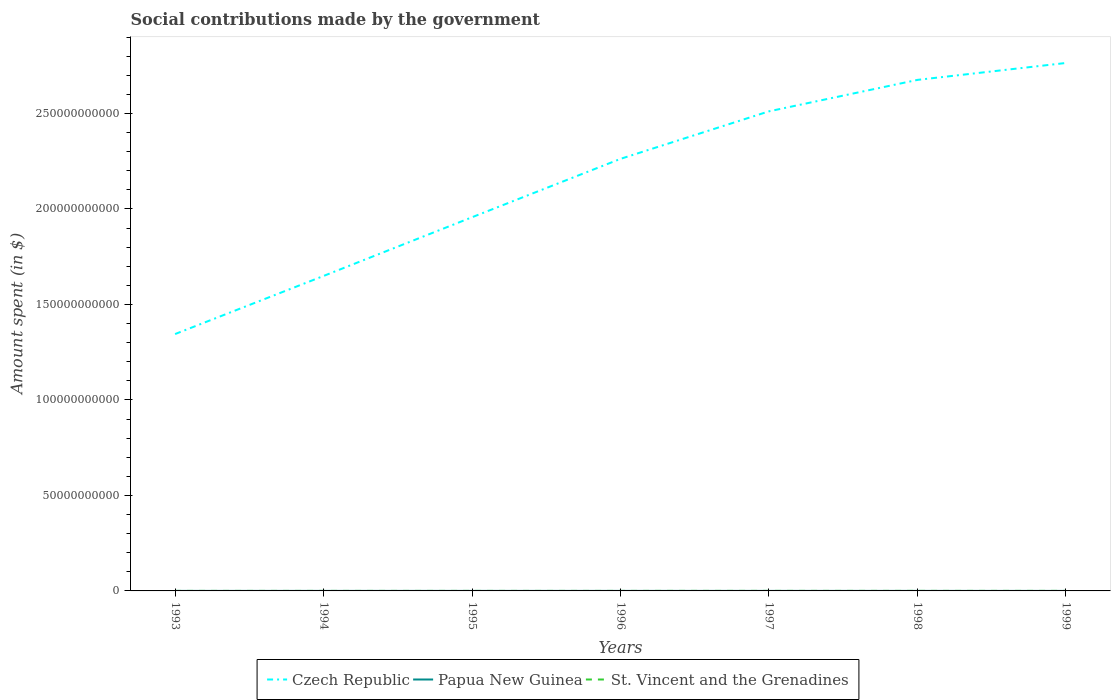How many different coloured lines are there?
Make the answer very short. 3. Does the line corresponding to St. Vincent and the Grenadines intersect with the line corresponding to Czech Republic?
Keep it short and to the point. No. Is the number of lines equal to the number of legend labels?
Give a very brief answer. Yes. Across all years, what is the maximum amount spent on social contributions in St. Vincent and the Grenadines?
Give a very brief answer. 9.10e+06. In which year was the amount spent on social contributions in St. Vincent and the Grenadines maximum?
Keep it short and to the point. 1993. What is the total amount spent on social contributions in St. Vincent and the Grenadines in the graph?
Provide a short and direct response. -2.50e+06. What is the difference between the highest and the second highest amount spent on social contributions in St. Vincent and the Grenadines?
Make the answer very short. 7.00e+06. How many lines are there?
Make the answer very short. 3. How many years are there in the graph?
Offer a very short reply. 7. Does the graph contain any zero values?
Offer a terse response. No. How many legend labels are there?
Give a very brief answer. 3. What is the title of the graph?
Provide a short and direct response. Social contributions made by the government. Does "Grenada" appear as one of the legend labels in the graph?
Keep it short and to the point. No. What is the label or title of the X-axis?
Offer a very short reply. Years. What is the label or title of the Y-axis?
Ensure brevity in your answer.  Amount spent (in $). What is the Amount spent (in $) in Czech Republic in 1993?
Provide a short and direct response. 1.34e+11. What is the Amount spent (in $) in Papua New Guinea in 1993?
Ensure brevity in your answer.  6.53e+06. What is the Amount spent (in $) in St. Vincent and the Grenadines in 1993?
Provide a short and direct response. 9.10e+06. What is the Amount spent (in $) in Czech Republic in 1994?
Keep it short and to the point. 1.65e+11. What is the Amount spent (in $) in Papua New Guinea in 1994?
Offer a terse response. 6.30e+06. What is the Amount spent (in $) of St. Vincent and the Grenadines in 1994?
Provide a short and direct response. 9.50e+06. What is the Amount spent (in $) of Czech Republic in 1995?
Offer a terse response. 1.96e+11. What is the Amount spent (in $) in Papua New Guinea in 1995?
Your answer should be very brief. 7.29e+06. What is the Amount spent (in $) of St. Vincent and the Grenadines in 1995?
Ensure brevity in your answer.  1.07e+07. What is the Amount spent (in $) in Czech Republic in 1996?
Make the answer very short. 2.26e+11. What is the Amount spent (in $) of Papua New Guinea in 1996?
Offer a terse response. 7.87e+06. What is the Amount spent (in $) in St. Vincent and the Grenadines in 1996?
Keep it short and to the point. 1.16e+07. What is the Amount spent (in $) in Czech Republic in 1997?
Your answer should be compact. 2.51e+11. What is the Amount spent (in $) of Papua New Guinea in 1997?
Your answer should be very brief. 5.77e+06. What is the Amount spent (in $) of St. Vincent and the Grenadines in 1997?
Keep it short and to the point. 1.36e+07. What is the Amount spent (in $) of Czech Republic in 1998?
Your answer should be very brief. 2.68e+11. What is the Amount spent (in $) of Papua New Guinea in 1998?
Your answer should be very brief. 4.65e+06. What is the Amount spent (in $) of St. Vincent and the Grenadines in 1998?
Your answer should be compact. 1.54e+07. What is the Amount spent (in $) in Czech Republic in 1999?
Your answer should be compact. 2.76e+11. What is the Amount spent (in $) of Papua New Guinea in 1999?
Give a very brief answer. 3.53e+06. What is the Amount spent (in $) of St. Vincent and the Grenadines in 1999?
Your response must be concise. 1.61e+07. Across all years, what is the maximum Amount spent (in $) in Czech Republic?
Your answer should be very brief. 2.76e+11. Across all years, what is the maximum Amount spent (in $) in Papua New Guinea?
Provide a short and direct response. 7.87e+06. Across all years, what is the maximum Amount spent (in $) of St. Vincent and the Grenadines?
Provide a succinct answer. 1.61e+07. Across all years, what is the minimum Amount spent (in $) in Czech Republic?
Keep it short and to the point. 1.34e+11. Across all years, what is the minimum Amount spent (in $) of Papua New Guinea?
Offer a very short reply. 3.53e+06. Across all years, what is the minimum Amount spent (in $) of St. Vincent and the Grenadines?
Offer a terse response. 9.10e+06. What is the total Amount spent (in $) in Czech Republic in the graph?
Make the answer very short. 1.52e+12. What is the total Amount spent (in $) in Papua New Guinea in the graph?
Provide a succinct answer. 4.19e+07. What is the total Amount spent (in $) in St. Vincent and the Grenadines in the graph?
Your answer should be compact. 8.60e+07. What is the difference between the Amount spent (in $) in Czech Republic in 1993 and that in 1994?
Offer a terse response. -3.04e+1. What is the difference between the Amount spent (in $) in Papua New Guinea in 1993 and that in 1994?
Keep it short and to the point. 2.26e+05. What is the difference between the Amount spent (in $) in St. Vincent and the Grenadines in 1993 and that in 1994?
Ensure brevity in your answer.  -4.00e+05. What is the difference between the Amount spent (in $) in Czech Republic in 1993 and that in 1995?
Your answer should be compact. -6.12e+1. What is the difference between the Amount spent (in $) in Papua New Guinea in 1993 and that in 1995?
Your answer should be compact. -7.57e+05. What is the difference between the Amount spent (in $) of St. Vincent and the Grenadines in 1993 and that in 1995?
Your answer should be very brief. -1.60e+06. What is the difference between the Amount spent (in $) of Czech Republic in 1993 and that in 1996?
Offer a very short reply. -9.17e+1. What is the difference between the Amount spent (in $) in Papua New Guinea in 1993 and that in 1996?
Keep it short and to the point. -1.34e+06. What is the difference between the Amount spent (in $) of St. Vincent and the Grenadines in 1993 and that in 1996?
Provide a short and direct response. -2.50e+06. What is the difference between the Amount spent (in $) in Czech Republic in 1993 and that in 1997?
Your answer should be compact. -1.17e+11. What is the difference between the Amount spent (in $) of Papua New Guinea in 1993 and that in 1997?
Keep it short and to the point. 7.60e+05. What is the difference between the Amount spent (in $) of St. Vincent and the Grenadines in 1993 and that in 1997?
Provide a short and direct response. -4.50e+06. What is the difference between the Amount spent (in $) in Czech Republic in 1993 and that in 1998?
Offer a terse response. -1.33e+11. What is the difference between the Amount spent (in $) of Papua New Guinea in 1993 and that in 1998?
Keep it short and to the point. 1.88e+06. What is the difference between the Amount spent (in $) of St. Vincent and the Grenadines in 1993 and that in 1998?
Your answer should be very brief. -6.30e+06. What is the difference between the Amount spent (in $) of Czech Republic in 1993 and that in 1999?
Make the answer very short. -1.42e+11. What is the difference between the Amount spent (in $) of Papua New Guinea in 1993 and that in 1999?
Your answer should be very brief. 3.00e+06. What is the difference between the Amount spent (in $) of St. Vincent and the Grenadines in 1993 and that in 1999?
Your response must be concise. -7.00e+06. What is the difference between the Amount spent (in $) in Czech Republic in 1994 and that in 1995?
Your response must be concise. -3.07e+1. What is the difference between the Amount spent (in $) of Papua New Guinea in 1994 and that in 1995?
Your response must be concise. -9.83e+05. What is the difference between the Amount spent (in $) in St. Vincent and the Grenadines in 1994 and that in 1995?
Offer a terse response. -1.20e+06. What is the difference between the Amount spent (in $) of Czech Republic in 1994 and that in 1996?
Your response must be concise. -6.13e+1. What is the difference between the Amount spent (in $) in Papua New Guinea in 1994 and that in 1996?
Give a very brief answer. -1.57e+06. What is the difference between the Amount spent (in $) of St. Vincent and the Grenadines in 1994 and that in 1996?
Offer a very short reply. -2.10e+06. What is the difference between the Amount spent (in $) of Czech Republic in 1994 and that in 1997?
Offer a very short reply. -8.62e+1. What is the difference between the Amount spent (in $) of Papua New Guinea in 1994 and that in 1997?
Provide a succinct answer. 5.34e+05. What is the difference between the Amount spent (in $) in St. Vincent and the Grenadines in 1994 and that in 1997?
Your response must be concise. -4.10e+06. What is the difference between the Amount spent (in $) of Czech Republic in 1994 and that in 1998?
Your answer should be compact. -1.03e+11. What is the difference between the Amount spent (in $) in Papua New Guinea in 1994 and that in 1998?
Make the answer very short. 1.65e+06. What is the difference between the Amount spent (in $) in St. Vincent and the Grenadines in 1994 and that in 1998?
Give a very brief answer. -5.90e+06. What is the difference between the Amount spent (in $) in Czech Republic in 1994 and that in 1999?
Make the answer very short. -1.12e+11. What is the difference between the Amount spent (in $) of Papua New Guinea in 1994 and that in 1999?
Provide a succinct answer. 2.78e+06. What is the difference between the Amount spent (in $) in St. Vincent and the Grenadines in 1994 and that in 1999?
Give a very brief answer. -6.60e+06. What is the difference between the Amount spent (in $) of Czech Republic in 1995 and that in 1996?
Your answer should be compact. -3.06e+1. What is the difference between the Amount spent (in $) in Papua New Guinea in 1995 and that in 1996?
Your answer should be very brief. -5.87e+05. What is the difference between the Amount spent (in $) of St. Vincent and the Grenadines in 1995 and that in 1996?
Keep it short and to the point. -9.00e+05. What is the difference between the Amount spent (in $) of Czech Republic in 1995 and that in 1997?
Provide a short and direct response. -5.55e+1. What is the difference between the Amount spent (in $) of Papua New Guinea in 1995 and that in 1997?
Offer a very short reply. 1.52e+06. What is the difference between the Amount spent (in $) in St. Vincent and the Grenadines in 1995 and that in 1997?
Your answer should be compact. -2.90e+06. What is the difference between the Amount spent (in $) of Czech Republic in 1995 and that in 1998?
Your answer should be compact. -7.19e+1. What is the difference between the Amount spent (in $) of Papua New Guinea in 1995 and that in 1998?
Make the answer very short. 2.64e+06. What is the difference between the Amount spent (in $) in St. Vincent and the Grenadines in 1995 and that in 1998?
Your answer should be compact. -4.70e+06. What is the difference between the Amount spent (in $) of Czech Republic in 1995 and that in 1999?
Keep it short and to the point. -8.08e+1. What is the difference between the Amount spent (in $) of Papua New Guinea in 1995 and that in 1999?
Give a very brief answer. 3.76e+06. What is the difference between the Amount spent (in $) of St. Vincent and the Grenadines in 1995 and that in 1999?
Offer a terse response. -5.40e+06. What is the difference between the Amount spent (in $) of Czech Republic in 1996 and that in 1997?
Ensure brevity in your answer.  -2.49e+1. What is the difference between the Amount spent (in $) in Papua New Guinea in 1996 and that in 1997?
Give a very brief answer. 2.10e+06. What is the difference between the Amount spent (in $) of St. Vincent and the Grenadines in 1996 and that in 1997?
Ensure brevity in your answer.  -2.00e+06. What is the difference between the Amount spent (in $) of Czech Republic in 1996 and that in 1998?
Your response must be concise. -4.13e+1. What is the difference between the Amount spent (in $) in Papua New Guinea in 1996 and that in 1998?
Ensure brevity in your answer.  3.22e+06. What is the difference between the Amount spent (in $) of St. Vincent and the Grenadines in 1996 and that in 1998?
Your answer should be very brief. -3.80e+06. What is the difference between the Amount spent (in $) in Czech Republic in 1996 and that in 1999?
Provide a short and direct response. -5.02e+1. What is the difference between the Amount spent (in $) in Papua New Guinea in 1996 and that in 1999?
Give a very brief answer. 4.35e+06. What is the difference between the Amount spent (in $) in St. Vincent and the Grenadines in 1996 and that in 1999?
Provide a short and direct response. -4.50e+06. What is the difference between the Amount spent (in $) of Czech Republic in 1997 and that in 1998?
Provide a short and direct response. -1.65e+1. What is the difference between the Amount spent (in $) of Papua New Guinea in 1997 and that in 1998?
Provide a short and direct response. 1.12e+06. What is the difference between the Amount spent (in $) in St. Vincent and the Grenadines in 1997 and that in 1998?
Your answer should be compact. -1.80e+06. What is the difference between the Amount spent (in $) of Czech Republic in 1997 and that in 1999?
Your response must be concise. -2.53e+1. What is the difference between the Amount spent (in $) in Papua New Guinea in 1997 and that in 1999?
Offer a very short reply. 2.24e+06. What is the difference between the Amount spent (in $) of St. Vincent and the Grenadines in 1997 and that in 1999?
Offer a very short reply. -2.50e+06. What is the difference between the Amount spent (in $) of Czech Republic in 1998 and that in 1999?
Ensure brevity in your answer.  -8.86e+09. What is the difference between the Amount spent (in $) in Papua New Guinea in 1998 and that in 1999?
Offer a terse response. 1.12e+06. What is the difference between the Amount spent (in $) in St. Vincent and the Grenadines in 1998 and that in 1999?
Offer a very short reply. -7.00e+05. What is the difference between the Amount spent (in $) in Czech Republic in 1993 and the Amount spent (in $) in Papua New Guinea in 1994?
Offer a very short reply. 1.34e+11. What is the difference between the Amount spent (in $) of Czech Republic in 1993 and the Amount spent (in $) of St. Vincent and the Grenadines in 1994?
Your response must be concise. 1.34e+11. What is the difference between the Amount spent (in $) of Papua New Guinea in 1993 and the Amount spent (in $) of St. Vincent and the Grenadines in 1994?
Provide a short and direct response. -2.97e+06. What is the difference between the Amount spent (in $) in Czech Republic in 1993 and the Amount spent (in $) in Papua New Guinea in 1995?
Ensure brevity in your answer.  1.34e+11. What is the difference between the Amount spent (in $) of Czech Republic in 1993 and the Amount spent (in $) of St. Vincent and the Grenadines in 1995?
Your response must be concise. 1.34e+11. What is the difference between the Amount spent (in $) of Papua New Guinea in 1993 and the Amount spent (in $) of St. Vincent and the Grenadines in 1995?
Provide a succinct answer. -4.17e+06. What is the difference between the Amount spent (in $) of Czech Republic in 1993 and the Amount spent (in $) of Papua New Guinea in 1996?
Provide a succinct answer. 1.34e+11. What is the difference between the Amount spent (in $) of Czech Republic in 1993 and the Amount spent (in $) of St. Vincent and the Grenadines in 1996?
Provide a succinct answer. 1.34e+11. What is the difference between the Amount spent (in $) of Papua New Guinea in 1993 and the Amount spent (in $) of St. Vincent and the Grenadines in 1996?
Your answer should be compact. -5.07e+06. What is the difference between the Amount spent (in $) of Czech Republic in 1993 and the Amount spent (in $) of Papua New Guinea in 1997?
Make the answer very short. 1.34e+11. What is the difference between the Amount spent (in $) of Czech Republic in 1993 and the Amount spent (in $) of St. Vincent and the Grenadines in 1997?
Give a very brief answer. 1.34e+11. What is the difference between the Amount spent (in $) in Papua New Guinea in 1993 and the Amount spent (in $) in St. Vincent and the Grenadines in 1997?
Offer a terse response. -7.07e+06. What is the difference between the Amount spent (in $) in Czech Republic in 1993 and the Amount spent (in $) in Papua New Guinea in 1998?
Provide a succinct answer. 1.34e+11. What is the difference between the Amount spent (in $) in Czech Republic in 1993 and the Amount spent (in $) in St. Vincent and the Grenadines in 1998?
Your answer should be very brief. 1.34e+11. What is the difference between the Amount spent (in $) of Papua New Guinea in 1993 and the Amount spent (in $) of St. Vincent and the Grenadines in 1998?
Make the answer very short. -8.87e+06. What is the difference between the Amount spent (in $) in Czech Republic in 1993 and the Amount spent (in $) in Papua New Guinea in 1999?
Your response must be concise. 1.34e+11. What is the difference between the Amount spent (in $) in Czech Republic in 1993 and the Amount spent (in $) in St. Vincent and the Grenadines in 1999?
Offer a very short reply. 1.34e+11. What is the difference between the Amount spent (in $) in Papua New Guinea in 1993 and the Amount spent (in $) in St. Vincent and the Grenadines in 1999?
Make the answer very short. -9.57e+06. What is the difference between the Amount spent (in $) of Czech Republic in 1994 and the Amount spent (in $) of Papua New Guinea in 1995?
Offer a terse response. 1.65e+11. What is the difference between the Amount spent (in $) in Czech Republic in 1994 and the Amount spent (in $) in St. Vincent and the Grenadines in 1995?
Your answer should be very brief. 1.65e+11. What is the difference between the Amount spent (in $) of Papua New Guinea in 1994 and the Amount spent (in $) of St. Vincent and the Grenadines in 1995?
Give a very brief answer. -4.40e+06. What is the difference between the Amount spent (in $) of Czech Republic in 1994 and the Amount spent (in $) of Papua New Guinea in 1996?
Your response must be concise. 1.65e+11. What is the difference between the Amount spent (in $) in Czech Republic in 1994 and the Amount spent (in $) in St. Vincent and the Grenadines in 1996?
Make the answer very short. 1.65e+11. What is the difference between the Amount spent (in $) in Papua New Guinea in 1994 and the Amount spent (in $) in St. Vincent and the Grenadines in 1996?
Offer a terse response. -5.30e+06. What is the difference between the Amount spent (in $) in Czech Republic in 1994 and the Amount spent (in $) in Papua New Guinea in 1997?
Make the answer very short. 1.65e+11. What is the difference between the Amount spent (in $) in Czech Republic in 1994 and the Amount spent (in $) in St. Vincent and the Grenadines in 1997?
Your response must be concise. 1.65e+11. What is the difference between the Amount spent (in $) in Papua New Guinea in 1994 and the Amount spent (in $) in St. Vincent and the Grenadines in 1997?
Give a very brief answer. -7.30e+06. What is the difference between the Amount spent (in $) in Czech Republic in 1994 and the Amount spent (in $) in Papua New Guinea in 1998?
Offer a very short reply. 1.65e+11. What is the difference between the Amount spent (in $) in Czech Republic in 1994 and the Amount spent (in $) in St. Vincent and the Grenadines in 1998?
Keep it short and to the point. 1.65e+11. What is the difference between the Amount spent (in $) of Papua New Guinea in 1994 and the Amount spent (in $) of St. Vincent and the Grenadines in 1998?
Provide a succinct answer. -9.10e+06. What is the difference between the Amount spent (in $) in Czech Republic in 1994 and the Amount spent (in $) in Papua New Guinea in 1999?
Provide a succinct answer. 1.65e+11. What is the difference between the Amount spent (in $) in Czech Republic in 1994 and the Amount spent (in $) in St. Vincent and the Grenadines in 1999?
Give a very brief answer. 1.65e+11. What is the difference between the Amount spent (in $) of Papua New Guinea in 1994 and the Amount spent (in $) of St. Vincent and the Grenadines in 1999?
Your response must be concise. -9.80e+06. What is the difference between the Amount spent (in $) of Czech Republic in 1995 and the Amount spent (in $) of Papua New Guinea in 1996?
Offer a terse response. 1.96e+11. What is the difference between the Amount spent (in $) in Czech Republic in 1995 and the Amount spent (in $) in St. Vincent and the Grenadines in 1996?
Give a very brief answer. 1.96e+11. What is the difference between the Amount spent (in $) in Papua New Guinea in 1995 and the Amount spent (in $) in St. Vincent and the Grenadines in 1996?
Offer a very short reply. -4.31e+06. What is the difference between the Amount spent (in $) in Czech Republic in 1995 and the Amount spent (in $) in Papua New Guinea in 1997?
Give a very brief answer. 1.96e+11. What is the difference between the Amount spent (in $) in Czech Republic in 1995 and the Amount spent (in $) in St. Vincent and the Grenadines in 1997?
Provide a short and direct response. 1.96e+11. What is the difference between the Amount spent (in $) in Papua New Guinea in 1995 and the Amount spent (in $) in St. Vincent and the Grenadines in 1997?
Your answer should be compact. -6.31e+06. What is the difference between the Amount spent (in $) in Czech Republic in 1995 and the Amount spent (in $) in Papua New Guinea in 1998?
Provide a succinct answer. 1.96e+11. What is the difference between the Amount spent (in $) of Czech Republic in 1995 and the Amount spent (in $) of St. Vincent and the Grenadines in 1998?
Ensure brevity in your answer.  1.96e+11. What is the difference between the Amount spent (in $) of Papua New Guinea in 1995 and the Amount spent (in $) of St. Vincent and the Grenadines in 1998?
Ensure brevity in your answer.  -8.11e+06. What is the difference between the Amount spent (in $) of Czech Republic in 1995 and the Amount spent (in $) of Papua New Guinea in 1999?
Give a very brief answer. 1.96e+11. What is the difference between the Amount spent (in $) of Czech Republic in 1995 and the Amount spent (in $) of St. Vincent and the Grenadines in 1999?
Ensure brevity in your answer.  1.96e+11. What is the difference between the Amount spent (in $) in Papua New Guinea in 1995 and the Amount spent (in $) in St. Vincent and the Grenadines in 1999?
Ensure brevity in your answer.  -8.81e+06. What is the difference between the Amount spent (in $) of Czech Republic in 1996 and the Amount spent (in $) of Papua New Guinea in 1997?
Offer a terse response. 2.26e+11. What is the difference between the Amount spent (in $) in Czech Republic in 1996 and the Amount spent (in $) in St. Vincent and the Grenadines in 1997?
Give a very brief answer. 2.26e+11. What is the difference between the Amount spent (in $) in Papua New Guinea in 1996 and the Amount spent (in $) in St. Vincent and the Grenadines in 1997?
Ensure brevity in your answer.  -5.73e+06. What is the difference between the Amount spent (in $) of Czech Republic in 1996 and the Amount spent (in $) of Papua New Guinea in 1998?
Keep it short and to the point. 2.26e+11. What is the difference between the Amount spent (in $) of Czech Republic in 1996 and the Amount spent (in $) of St. Vincent and the Grenadines in 1998?
Provide a short and direct response. 2.26e+11. What is the difference between the Amount spent (in $) of Papua New Guinea in 1996 and the Amount spent (in $) of St. Vincent and the Grenadines in 1998?
Provide a succinct answer. -7.53e+06. What is the difference between the Amount spent (in $) in Czech Republic in 1996 and the Amount spent (in $) in Papua New Guinea in 1999?
Offer a very short reply. 2.26e+11. What is the difference between the Amount spent (in $) in Czech Republic in 1996 and the Amount spent (in $) in St. Vincent and the Grenadines in 1999?
Ensure brevity in your answer.  2.26e+11. What is the difference between the Amount spent (in $) of Papua New Guinea in 1996 and the Amount spent (in $) of St. Vincent and the Grenadines in 1999?
Make the answer very short. -8.23e+06. What is the difference between the Amount spent (in $) of Czech Republic in 1997 and the Amount spent (in $) of Papua New Guinea in 1998?
Give a very brief answer. 2.51e+11. What is the difference between the Amount spent (in $) in Czech Republic in 1997 and the Amount spent (in $) in St. Vincent and the Grenadines in 1998?
Offer a very short reply. 2.51e+11. What is the difference between the Amount spent (in $) in Papua New Guinea in 1997 and the Amount spent (in $) in St. Vincent and the Grenadines in 1998?
Your response must be concise. -9.63e+06. What is the difference between the Amount spent (in $) of Czech Republic in 1997 and the Amount spent (in $) of Papua New Guinea in 1999?
Offer a very short reply. 2.51e+11. What is the difference between the Amount spent (in $) in Czech Republic in 1997 and the Amount spent (in $) in St. Vincent and the Grenadines in 1999?
Offer a terse response. 2.51e+11. What is the difference between the Amount spent (in $) in Papua New Guinea in 1997 and the Amount spent (in $) in St. Vincent and the Grenadines in 1999?
Ensure brevity in your answer.  -1.03e+07. What is the difference between the Amount spent (in $) in Czech Republic in 1998 and the Amount spent (in $) in Papua New Guinea in 1999?
Provide a succinct answer. 2.68e+11. What is the difference between the Amount spent (in $) of Czech Republic in 1998 and the Amount spent (in $) of St. Vincent and the Grenadines in 1999?
Offer a terse response. 2.68e+11. What is the difference between the Amount spent (in $) in Papua New Guinea in 1998 and the Amount spent (in $) in St. Vincent and the Grenadines in 1999?
Make the answer very short. -1.14e+07. What is the average Amount spent (in $) of Czech Republic per year?
Make the answer very short. 2.17e+11. What is the average Amount spent (in $) of Papua New Guinea per year?
Offer a terse response. 5.99e+06. What is the average Amount spent (in $) in St. Vincent and the Grenadines per year?
Your response must be concise. 1.23e+07. In the year 1993, what is the difference between the Amount spent (in $) in Czech Republic and Amount spent (in $) in Papua New Guinea?
Keep it short and to the point. 1.34e+11. In the year 1993, what is the difference between the Amount spent (in $) in Czech Republic and Amount spent (in $) in St. Vincent and the Grenadines?
Make the answer very short. 1.34e+11. In the year 1993, what is the difference between the Amount spent (in $) in Papua New Guinea and Amount spent (in $) in St. Vincent and the Grenadines?
Provide a short and direct response. -2.57e+06. In the year 1994, what is the difference between the Amount spent (in $) of Czech Republic and Amount spent (in $) of Papua New Guinea?
Offer a terse response. 1.65e+11. In the year 1994, what is the difference between the Amount spent (in $) in Czech Republic and Amount spent (in $) in St. Vincent and the Grenadines?
Keep it short and to the point. 1.65e+11. In the year 1994, what is the difference between the Amount spent (in $) of Papua New Guinea and Amount spent (in $) of St. Vincent and the Grenadines?
Give a very brief answer. -3.20e+06. In the year 1995, what is the difference between the Amount spent (in $) in Czech Republic and Amount spent (in $) in Papua New Guinea?
Your response must be concise. 1.96e+11. In the year 1995, what is the difference between the Amount spent (in $) in Czech Republic and Amount spent (in $) in St. Vincent and the Grenadines?
Ensure brevity in your answer.  1.96e+11. In the year 1995, what is the difference between the Amount spent (in $) of Papua New Guinea and Amount spent (in $) of St. Vincent and the Grenadines?
Keep it short and to the point. -3.41e+06. In the year 1996, what is the difference between the Amount spent (in $) of Czech Republic and Amount spent (in $) of Papua New Guinea?
Offer a very short reply. 2.26e+11. In the year 1996, what is the difference between the Amount spent (in $) of Czech Republic and Amount spent (in $) of St. Vincent and the Grenadines?
Your response must be concise. 2.26e+11. In the year 1996, what is the difference between the Amount spent (in $) in Papua New Guinea and Amount spent (in $) in St. Vincent and the Grenadines?
Offer a terse response. -3.73e+06. In the year 1997, what is the difference between the Amount spent (in $) in Czech Republic and Amount spent (in $) in Papua New Guinea?
Keep it short and to the point. 2.51e+11. In the year 1997, what is the difference between the Amount spent (in $) in Czech Republic and Amount spent (in $) in St. Vincent and the Grenadines?
Provide a succinct answer. 2.51e+11. In the year 1997, what is the difference between the Amount spent (in $) in Papua New Guinea and Amount spent (in $) in St. Vincent and the Grenadines?
Give a very brief answer. -7.83e+06. In the year 1998, what is the difference between the Amount spent (in $) of Czech Republic and Amount spent (in $) of Papua New Guinea?
Make the answer very short. 2.68e+11. In the year 1998, what is the difference between the Amount spent (in $) of Czech Republic and Amount spent (in $) of St. Vincent and the Grenadines?
Your response must be concise. 2.68e+11. In the year 1998, what is the difference between the Amount spent (in $) in Papua New Guinea and Amount spent (in $) in St. Vincent and the Grenadines?
Your answer should be very brief. -1.08e+07. In the year 1999, what is the difference between the Amount spent (in $) in Czech Republic and Amount spent (in $) in Papua New Guinea?
Your answer should be compact. 2.76e+11. In the year 1999, what is the difference between the Amount spent (in $) of Czech Republic and Amount spent (in $) of St. Vincent and the Grenadines?
Provide a succinct answer. 2.76e+11. In the year 1999, what is the difference between the Amount spent (in $) of Papua New Guinea and Amount spent (in $) of St. Vincent and the Grenadines?
Ensure brevity in your answer.  -1.26e+07. What is the ratio of the Amount spent (in $) in Czech Republic in 1993 to that in 1994?
Keep it short and to the point. 0.82. What is the ratio of the Amount spent (in $) in Papua New Guinea in 1993 to that in 1994?
Your answer should be very brief. 1.04. What is the ratio of the Amount spent (in $) of St. Vincent and the Grenadines in 1993 to that in 1994?
Your answer should be compact. 0.96. What is the ratio of the Amount spent (in $) of Czech Republic in 1993 to that in 1995?
Ensure brevity in your answer.  0.69. What is the ratio of the Amount spent (in $) in Papua New Guinea in 1993 to that in 1995?
Make the answer very short. 0.9. What is the ratio of the Amount spent (in $) in St. Vincent and the Grenadines in 1993 to that in 1995?
Ensure brevity in your answer.  0.85. What is the ratio of the Amount spent (in $) in Czech Republic in 1993 to that in 1996?
Keep it short and to the point. 0.59. What is the ratio of the Amount spent (in $) of Papua New Guinea in 1993 to that in 1996?
Keep it short and to the point. 0.83. What is the ratio of the Amount spent (in $) of St. Vincent and the Grenadines in 1993 to that in 1996?
Provide a short and direct response. 0.78. What is the ratio of the Amount spent (in $) of Czech Republic in 1993 to that in 1997?
Ensure brevity in your answer.  0.54. What is the ratio of the Amount spent (in $) in Papua New Guinea in 1993 to that in 1997?
Your answer should be compact. 1.13. What is the ratio of the Amount spent (in $) in St. Vincent and the Grenadines in 1993 to that in 1997?
Ensure brevity in your answer.  0.67. What is the ratio of the Amount spent (in $) of Czech Republic in 1993 to that in 1998?
Keep it short and to the point. 0.5. What is the ratio of the Amount spent (in $) of Papua New Guinea in 1993 to that in 1998?
Your response must be concise. 1.4. What is the ratio of the Amount spent (in $) in St. Vincent and the Grenadines in 1993 to that in 1998?
Ensure brevity in your answer.  0.59. What is the ratio of the Amount spent (in $) of Czech Republic in 1993 to that in 1999?
Keep it short and to the point. 0.49. What is the ratio of the Amount spent (in $) in Papua New Guinea in 1993 to that in 1999?
Offer a very short reply. 1.85. What is the ratio of the Amount spent (in $) in St. Vincent and the Grenadines in 1993 to that in 1999?
Your answer should be very brief. 0.57. What is the ratio of the Amount spent (in $) of Czech Republic in 1994 to that in 1995?
Your answer should be compact. 0.84. What is the ratio of the Amount spent (in $) of Papua New Guinea in 1994 to that in 1995?
Make the answer very short. 0.87. What is the ratio of the Amount spent (in $) in St. Vincent and the Grenadines in 1994 to that in 1995?
Offer a very short reply. 0.89. What is the ratio of the Amount spent (in $) of Czech Republic in 1994 to that in 1996?
Make the answer very short. 0.73. What is the ratio of the Amount spent (in $) of Papua New Guinea in 1994 to that in 1996?
Make the answer very short. 0.8. What is the ratio of the Amount spent (in $) of St. Vincent and the Grenadines in 1994 to that in 1996?
Your answer should be compact. 0.82. What is the ratio of the Amount spent (in $) in Czech Republic in 1994 to that in 1997?
Your answer should be compact. 0.66. What is the ratio of the Amount spent (in $) in Papua New Guinea in 1994 to that in 1997?
Give a very brief answer. 1.09. What is the ratio of the Amount spent (in $) of St. Vincent and the Grenadines in 1994 to that in 1997?
Keep it short and to the point. 0.7. What is the ratio of the Amount spent (in $) in Czech Republic in 1994 to that in 1998?
Offer a very short reply. 0.62. What is the ratio of the Amount spent (in $) of Papua New Guinea in 1994 to that in 1998?
Provide a succinct answer. 1.36. What is the ratio of the Amount spent (in $) in St. Vincent and the Grenadines in 1994 to that in 1998?
Provide a short and direct response. 0.62. What is the ratio of the Amount spent (in $) in Czech Republic in 1994 to that in 1999?
Offer a terse response. 0.6. What is the ratio of the Amount spent (in $) of Papua New Guinea in 1994 to that in 1999?
Ensure brevity in your answer.  1.79. What is the ratio of the Amount spent (in $) in St. Vincent and the Grenadines in 1994 to that in 1999?
Provide a succinct answer. 0.59. What is the ratio of the Amount spent (in $) of Czech Republic in 1995 to that in 1996?
Keep it short and to the point. 0.86. What is the ratio of the Amount spent (in $) of Papua New Guinea in 1995 to that in 1996?
Provide a short and direct response. 0.93. What is the ratio of the Amount spent (in $) in St. Vincent and the Grenadines in 1995 to that in 1996?
Keep it short and to the point. 0.92. What is the ratio of the Amount spent (in $) in Czech Republic in 1995 to that in 1997?
Your answer should be very brief. 0.78. What is the ratio of the Amount spent (in $) in Papua New Guinea in 1995 to that in 1997?
Offer a very short reply. 1.26. What is the ratio of the Amount spent (in $) of St. Vincent and the Grenadines in 1995 to that in 1997?
Ensure brevity in your answer.  0.79. What is the ratio of the Amount spent (in $) of Czech Republic in 1995 to that in 1998?
Make the answer very short. 0.73. What is the ratio of the Amount spent (in $) of Papua New Guinea in 1995 to that in 1998?
Your answer should be compact. 1.57. What is the ratio of the Amount spent (in $) of St. Vincent and the Grenadines in 1995 to that in 1998?
Make the answer very short. 0.69. What is the ratio of the Amount spent (in $) of Czech Republic in 1995 to that in 1999?
Your response must be concise. 0.71. What is the ratio of the Amount spent (in $) in Papua New Guinea in 1995 to that in 1999?
Your answer should be compact. 2.07. What is the ratio of the Amount spent (in $) of St. Vincent and the Grenadines in 1995 to that in 1999?
Offer a terse response. 0.66. What is the ratio of the Amount spent (in $) in Czech Republic in 1996 to that in 1997?
Make the answer very short. 0.9. What is the ratio of the Amount spent (in $) of Papua New Guinea in 1996 to that in 1997?
Offer a very short reply. 1.36. What is the ratio of the Amount spent (in $) in St. Vincent and the Grenadines in 1996 to that in 1997?
Keep it short and to the point. 0.85. What is the ratio of the Amount spent (in $) of Czech Republic in 1996 to that in 1998?
Make the answer very short. 0.85. What is the ratio of the Amount spent (in $) in Papua New Guinea in 1996 to that in 1998?
Give a very brief answer. 1.69. What is the ratio of the Amount spent (in $) in St. Vincent and the Grenadines in 1996 to that in 1998?
Keep it short and to the point. 0.75. What is the ratio of the Amount spent (in $) of Czech Republic in 1996 to that in 1999?
Give a very brief answer. 0.82. What is the ratio of the Amount spent (in $) in Papua New Guinea in 1996 to that in 1999?
Provide a succinct answer. 2.23. What is the ratio of the Amount spent (in $) in St. Vincent and the Grenadines in 1996 to that in 1999?
Provide a short and direct response. 0.72. What is the ratio of the Amount spent (in $) in Czech Republic in 1997 to that in 1998?
Make the answer very short. 0.94. What is the ratio of the Amount spent (in $) in Papua New Guinea in 1997 to that in 1998?
Make the answer very short. 1.24. What is the ratio of the Amount spent (in $) of St. Vincent and the Grenadines in 1997 to that in 1998?
Give a very brief answer. 0.88. What is the ratio of the Amount spent (in $) in Czech Republic in 1997 to that in 1999?
Ensure brevity in your answer.  0.91. What is the ratio of the Amount spent (in $) of Papua New Guinea in 1997 to that in 1999?
Make the answer very short. 1.64. What is the ratio of the Amount spent (in $) of St. Vincent and the Grenadines in 1997 to that in 1999?
Offer a terse response. 0.84. What is the ratio of the Amount spent (in $) in Czech Republic in 1998 to that in 1999?
Your answer should be compact. 0.97. What is the ratio of the Amount spent (in $) in Papua New Guinea in 1998 to that in 1999?
Keep it short and to the point. 1.32. What is the ratio of the Amount spent (in $) in St. Vincent and the Grenadines in 1998 to that in 1999?
Your answer should be very brief. 0.96. What is the difference between the highest and the second highest Amount spent (in $) in Czech Republic?
Provide a succinct answer. 8.86e+09. What is the difference between the highest and the second highest Amount spent (in $) in Papua New Guinea?
Offer a very short reply. 5.87e+05. What is the difference between the highest and the second highest Amount spent (in $) of St. Vincent and the Grenadines?
Your answer should be compact. 7.00e+05. What is the difference between the highest and the lowest Amount spent (in $) in Czech Republic?
Provide a short and direct response. 1.42e+11. What is the difference between the highest and the lowest Amount spent (in $) in Papua New Guinea?
Your answer should be very brief. 4.35e+06. 